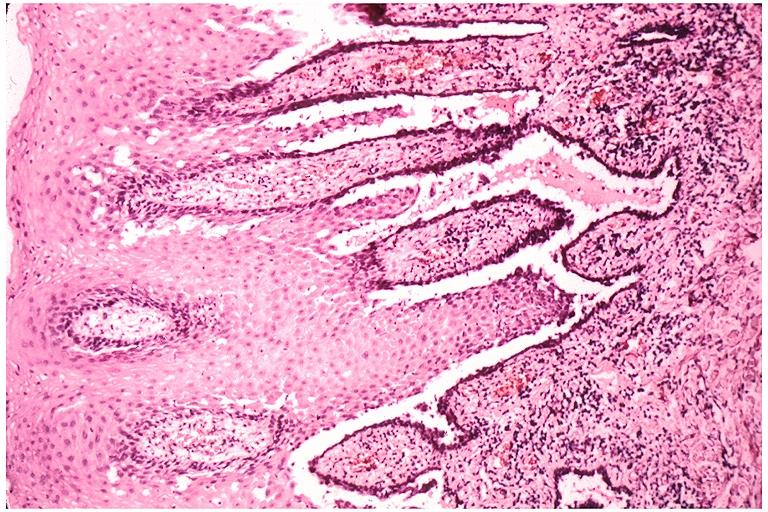where is this?
Answer the question using a single word or phrase. Oral 